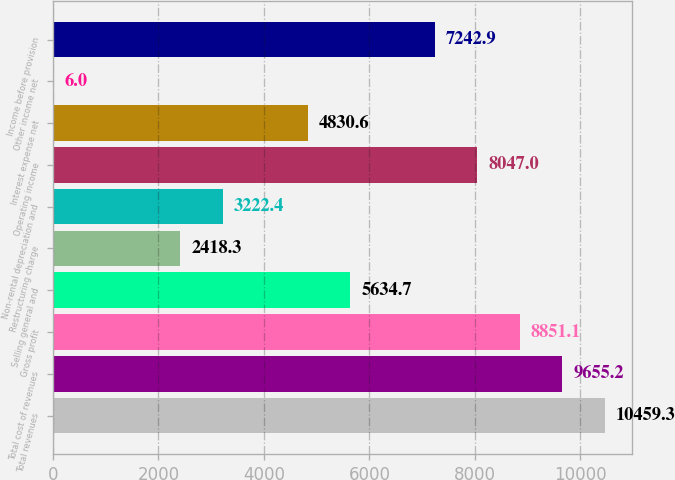Convert chart to OTSL. <chart><loc_0><loc_0><loc_500><loc_500><bar_chart><fcel>Total revenues<fcel>Total cost of revenues<fcel>Gross profit<fcel>Selling general and<fcel>Restructuring charge<fcel>Non-rental depreciation and<fcel>Operating income<fcel>Interest expense net<fcel>Other income net<fcel>Income before provision<nl><fcel>10459.3<fcel>9655.2<fcel>8851.1<fcel>5634.7<fcel>2418.3<fcel>3222.4<fcel>8047<fcel>4830.6<fcel>6<fcel>7242.9<nl></chart> 